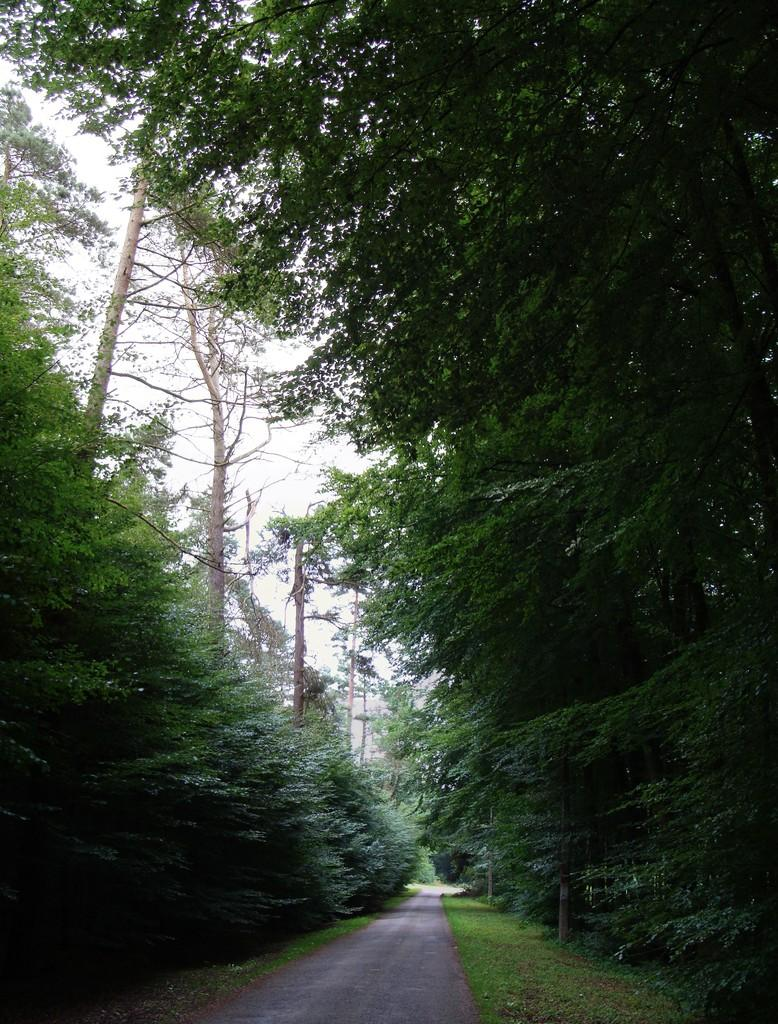What is the main feature of the image? There is a road in the image. What can be seen on either side of the road? There are trees on both the left and right sides of the road. What is visible in the background of the image? The sky is visible behind the trees. What type of feeling can be seen on the road in the image? There are no feelings present in the image; it is a photograph of a road with trees on either side and the sky visible in the background. Can you tell me how many bags of popcorn are on the road in the image? There are no bags of popcorn present in the image; it is a photograph of a road with trees on either side and the sky visible in the background. 